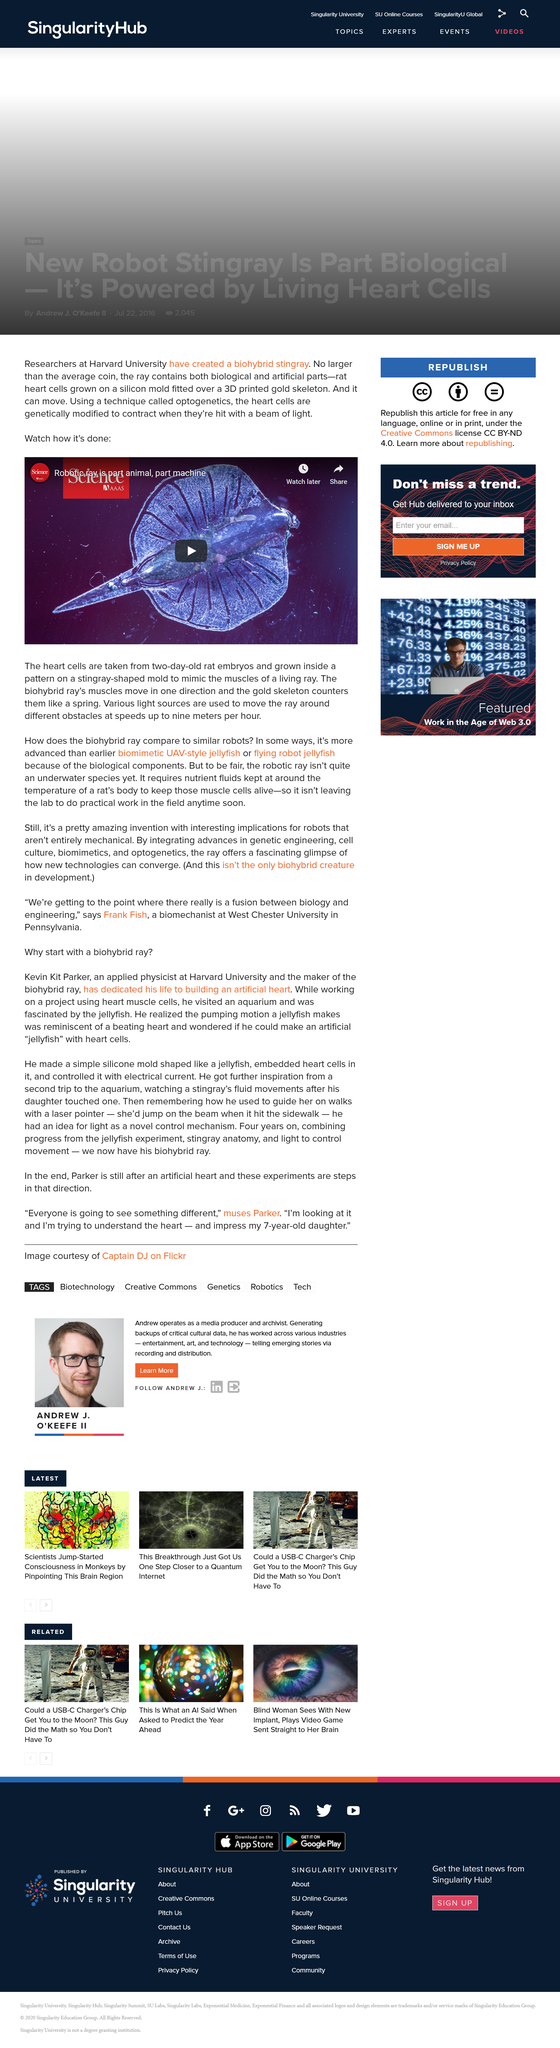Give some essential details in this illustration. Harvard University's researchers have developed a biohybrid stingray. The biohybrid stingray was created using animal cells, specifically rat heart cells, as its primary cell source. The biohybrid ray has the capability to travel at maximum speeds of nine meters per hour, which allows it to efficiently navigate and traverse various environments while maintaining optimal performance. 